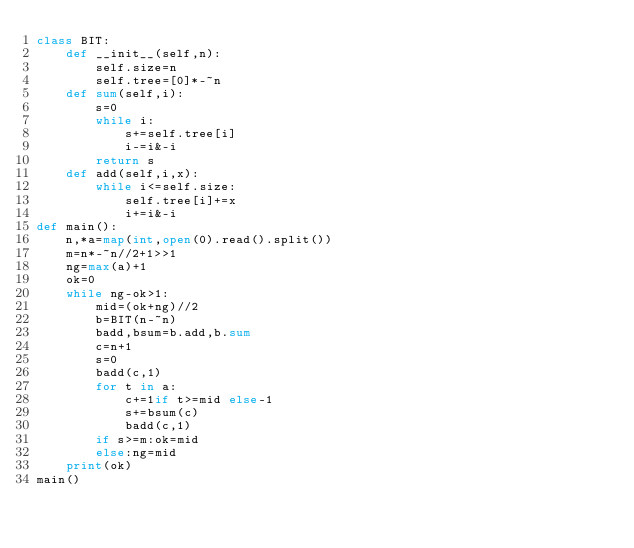Convert code to text. <code><loc_0><loc_0><loc_500><loc_500><_Python_>class BIT:
    def __init__(self,n):
        self.size=n
        self.tree=[0]*-~n
    def sum(self,i):
        s=0
        while i:
            s+=self.tree[i]
            i-=i&-i
        return s
    def add(self,i,x):
        while i<=self.size:
            self.tree[i]+=x
            i+=i&-i
def main():
    n,*a=map(int,open(0).read().split())
    m=n*-~n//2+1>>1
    ng=max(a)+1
    ok=0
    while ng-ok>1:
        mid=(ok+ng)//2
        b=BIT(n-~n)
        badd,bsum=b.add,b.sum
        c=n+1
        s=0
        badd(c,1)
        for t in a:
            c+=1if t>=mid else-1
            s+=bsum(c)
            badd(c,1)
        if s>=m:ok=mid
        else:ng=mid
    print(ok)
main()</code> 